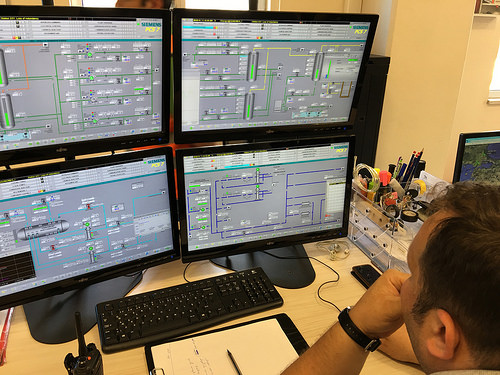<image>
Can you confirm if the pencil is next to the tape? Yes. The pencil is positioned adjacent to the tape, located nearby in the same general area. 